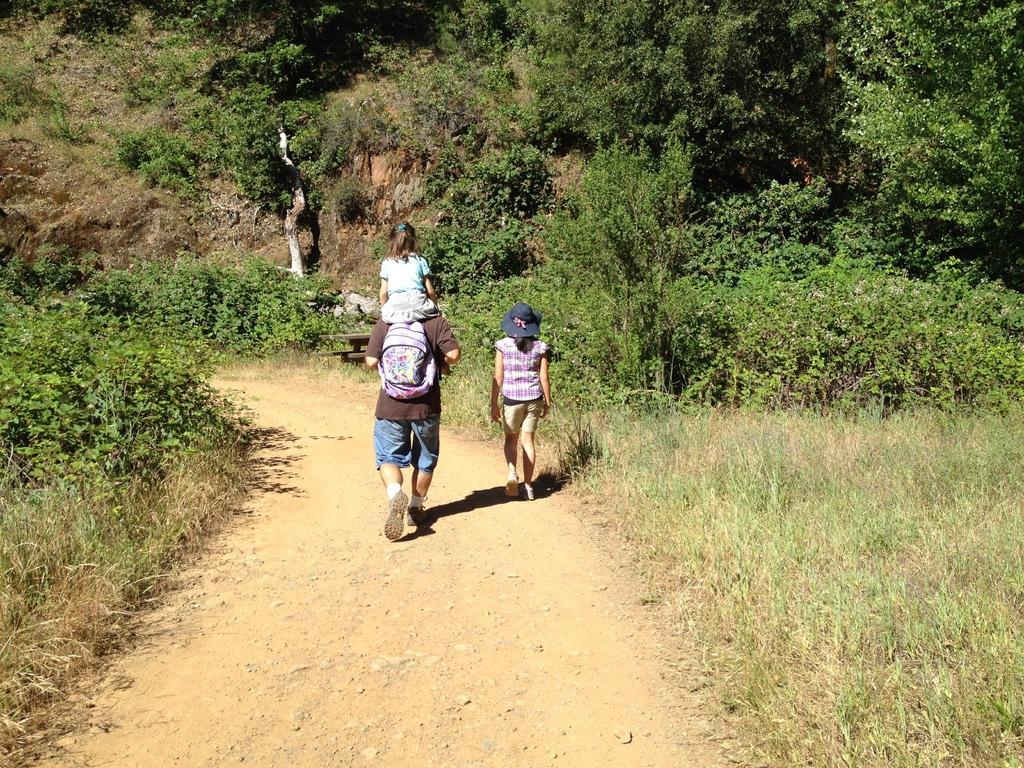Could you give a brief overview of what you see in this image? In this image I can see in the middle few persons are walking, at the back side there are trees. 